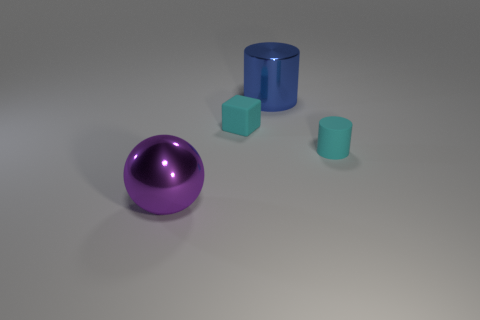Add 4 small purple cylinders. How many objects exist? 8 Subtract all cubes. How many objects are left? 3 Subtract 1 purple spheres. How many objects are left? 3 Subtract all blue cylinders. Subtract all small matte things. How many objects are left? 1 Add 1 small cyan things. How many small cyan things are left? 3 Add 4 cyan cylinders. How many cyan cylinders exist? 5 